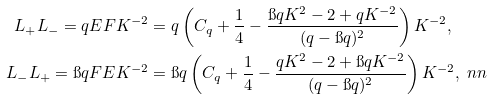Convert formula to latex. <formula><loc_0><loc_0><loc_500><loc_500>L _ { + } L _ { - } = q E F K ^ { - 2 } & = q \left ( C _ { q } + \frac { 1 } { 4 } - \frac { \i q K ^ { 2 } - 2 + q K ^ { - 2 } } { ( q - \i q ) ^ { 2 } } \right ) K ^ { - 2 } , \\ L _ { - } L _ { + } = \i q F E K ^ { - 2 } & = \i q \left ( C _ { q } + \frac { 1 } { 4 } - \frac { q K ^ { 2 } - 2 + \i q K ^ { - 2 } } { ( q - \i q ) ^ { 2 } } \right ) K ^ { - 2 } , \ n n</formula> 